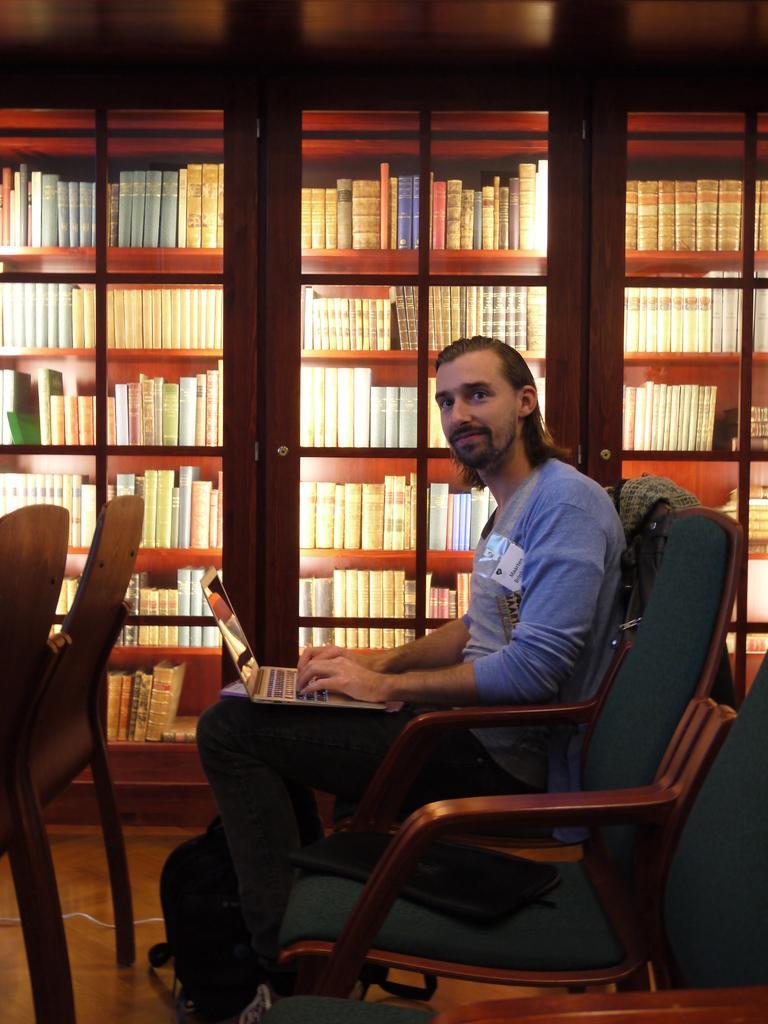Please provide a concise description of this image. This image is taken in indoors. In this image there is a man. In the middle of the image a man is sitting on the chair and using the laptop which is there on his lap. In the right side of the image there is an empty chair. In the background there are two cupboards with shelves and many books in it. In the left side of the image there are two empty chairs. 